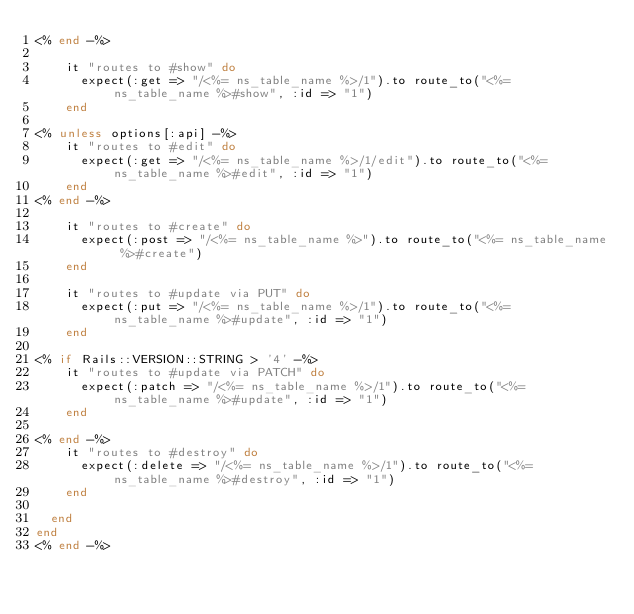Convert code to text. <code><loc_0><loc_0><loc_500><loc_500><_Ruby_><% end -%>

    it "routes to #show" do
      expect(:get => "/<%= ns_table_name %>/1").to route_to("<%= ns_table_name %>#show", :id => "1")
    end

<% unless options[:api] -%>
    it "routes to #edit" do
      expect(:get => "/<%= ns_table_name %>/1/edit").to route_to("<%= ns_table_name %>#edit", :id => "1")
    end
<% end -%>

    it "routes to #create" do
      expect(:post => "/<%= ns_table_name %>").to route_to("<%= ns_table_name %>#create")
    end

    it "routes to #update via PUT" do
      expect(:put => "/<%= ns_table_name %>/1").to route_to("<%= ns_table_name %>#update", :id => "1")
    end

<% if Rails::VERSION::STRING > '4' -%>
    it "routes to #update via PATCH" do
      expect(:patch => "/<%= ns_table_name %>/1").to route_to("<%= ns_table_name %>#update", :id => "1")
    end

<% end -%>
    it "routes to #destroy" do
      expect(:delete => "/<%= ns_table_name %>/1").to route_to("<%= ns_table_name %>#destroy", :id => "1")
    end

  end
end
<% end -%>
</code> 